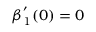<formula> <loc_0><loc_0><loc_500><loc_500>\beta _ { 1 } ^ { ^ { \prime } } ( 0 ) = 0</formula> 